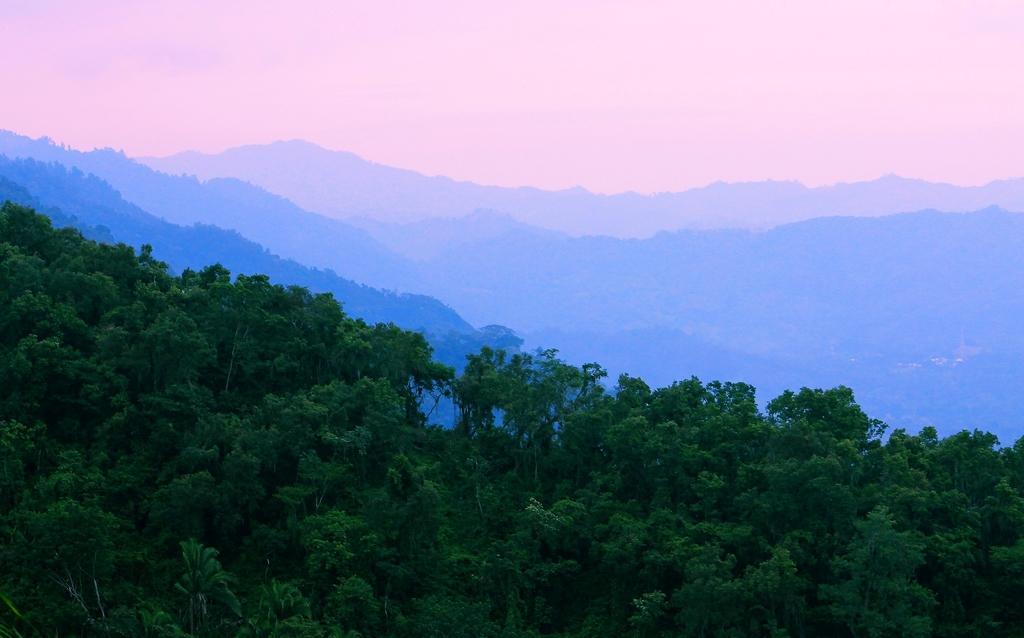In one or two sentences, can you explain what this image depicts? In this image we can see sky, hills and trees. 